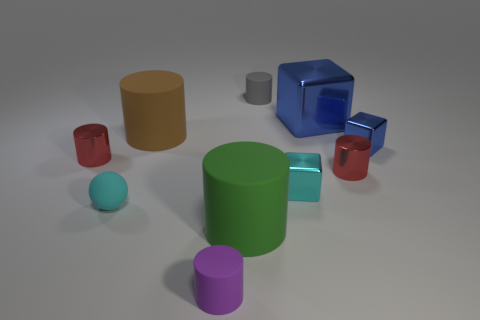Is there anything else that has the same size as the cyan shiny thing?
Make the answer very short. Yes. How big is the cyan block?
Provide a succinct answer. Small. How many tiny objects are either brown things or red matte cylinders?
Provide a succinct answer. 0. Does the cyan metal object have the same size as the blue block that is behind the tiny blue shiny object?
Offer a very short reply. No. Is there anything else that is the same shape as the purple object?
Offer a very short reply. Yes. What number of metallic blocks are there?
Your answer should be very brief. 3. How many blue things are balls or tiny matte objects?
Ensure brevity in your answer.  0. Do the small cylinder that is on the right side of the big blue metal block and the gray cylinder have the same material?
Provide a succinct answer. No. What number of other things are there of the same material as the brown object
Ensure brevity in your answer.  4. What is the material of the tiny gray thing?
Your answer should be very brief. Rubber. 